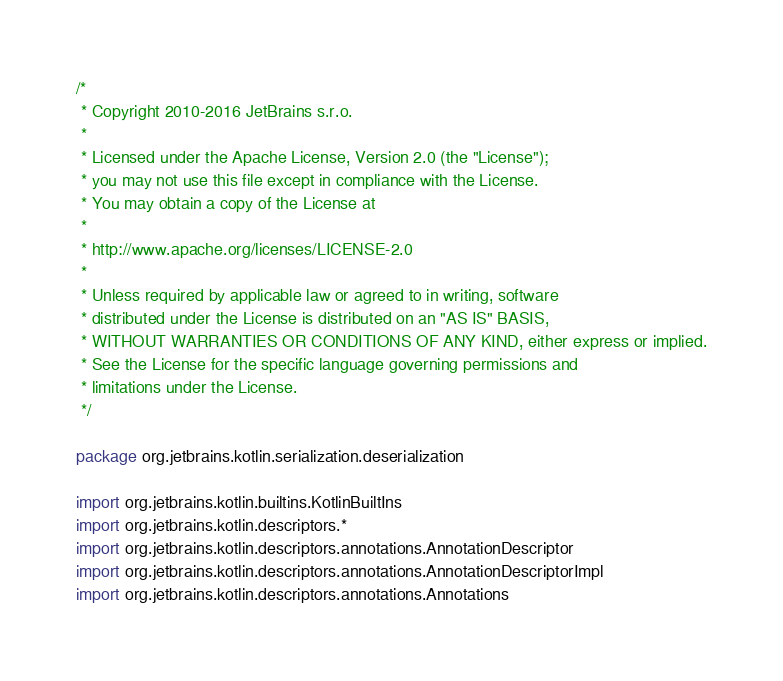<code> <loc_0><loc_0><loc_500><loc_500><_Kotlin_>/*
 * Copyright 2010-2016 JetBrains s.r.o.
 *
 * Licensed under the Apache License, Version 2.0 (the "License");
 * you may not use this file except in compliance with the License.
 * You may obtain a copy of the License at
 *
 * http://www.apache.org/licenses/LICENSE-2.0
 *
 * Unless required by applicable law or agreed to in writing, software
 * distributed under the License is distributed on an "AS IS" BASIS,
 * WITHOUT WARRANTIES OR CONDITIONS OF ANY KIND, either express or implied.
 * See the License for the specific language governing permissions and
 * limitations under the License.
 */

package org.jetbrains.kotlin.serialization.deserialization

import org.jetbrains.kotlin.builtins.KotlinBuiltIns
import org.jetbrains.kotlin.descriptors.*
import org.jetbrains.kotlin.descriptors.annotations.AnnotationDescriptor
import org.jetbrains.kotlin.descriptors.annotations.AnnotationDescriptorImpl
import org.jetbrains.kotlin.descriptors.annotations.Annotations</code> 